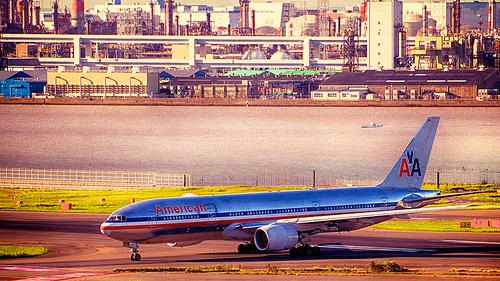Question: what is the focus?
Choices:
A. Dogs laying down.
B. Cows eating.
C. Airplane landing.
D. A flower.
Answer with the letter. Answer: C Question: how many wheels are on the front set of wheels?
Choices:
A. 3.
B. 4.
C. 2.
D. 1.
Answer with the letter. Answer: C Question: what does the plane say?
Choices:
A. American.
B. Delta.
C. American airlines.
D. Southwest.
Answer with the letter. Answer: A Question: what does the tail of the plane say?
Choices:
A. Sw.
B. Delta.
C. AA.
D. Ci.
Answer with the letter. Answer: C Question: what type of engines are on the plane?
Choices:
A. Three.
B. Turbine.
C. Propellers.
D. Round ones.
Answer with the letter. Answer: B 